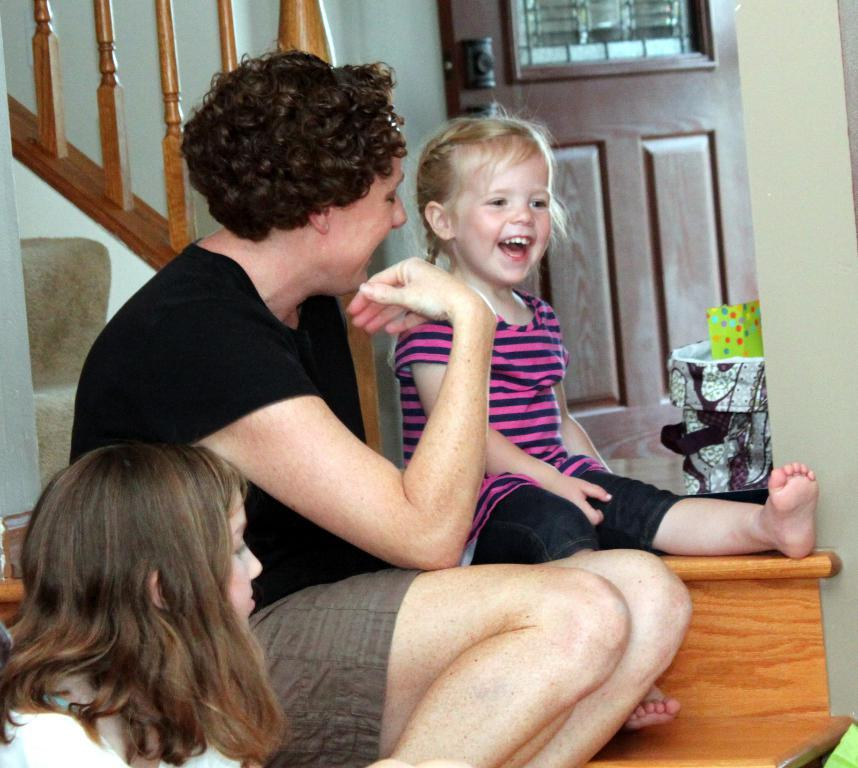How many people are in the image? There is one person and two children in the image. What are the person and children doing in the image? The person and children are sitting. What can be seen in the background of the image? There is a wall and a door visible in the image. What is visible in the sky in the image? Stars are visible in the image. What other objects can be seen in the image? There are other objects present in the image. What is the title of the book the person is reading in the image? There is no book visible in the image, so it is not possible to determine the title. 